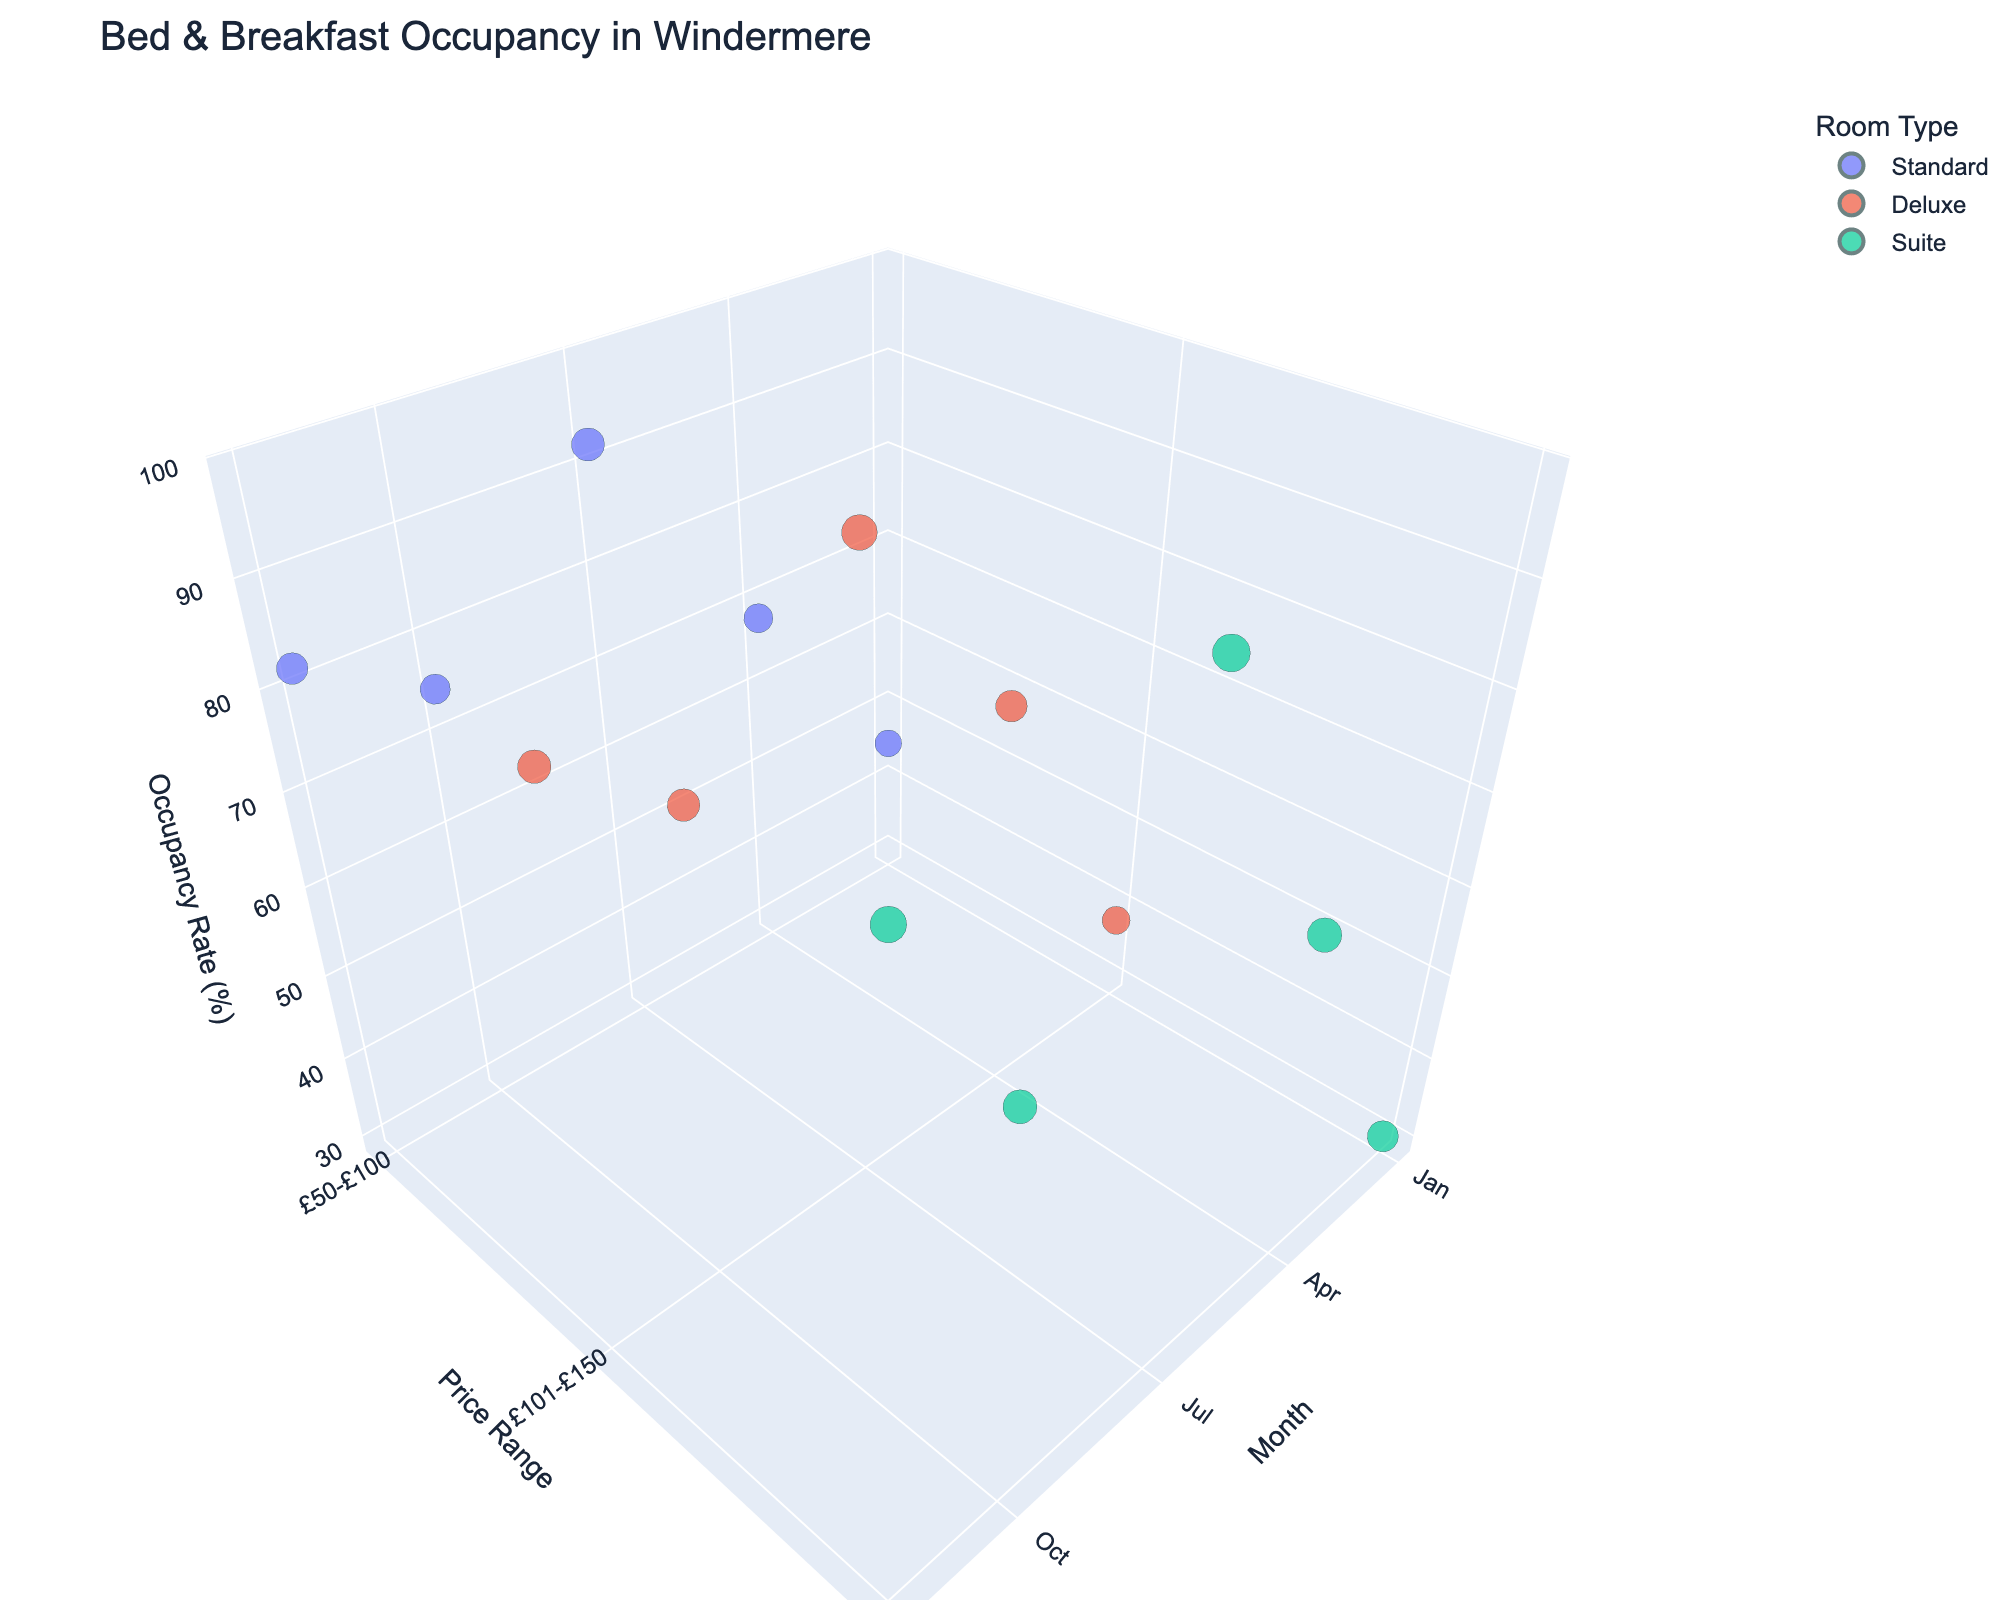What's the title of the chart? The title of the chart is the text displayed at the top of the figure, making it easily noticeable.
Answer: Bed & Breakfast Occupancy in Windermere What is the price range of Deluxe rooms? The price range is illustrated by the y-axis, and the Deluxe rooms are indicated by a specific color in the legend. Observing the corresponding price range shows it is £101-£150.
Answer: £101-£150 Which month has the highest occupancy rate for Suite rooms, and what is that rate? To determine this, locate the Suite room category by its color in the chart, and then identify the month with the highest z-axis (Occupancy Rate) value. July has the highest occupancy rate at 98%.
Answer: July, 98% Which room type typically has the longest average stay duration in December? Examine the bubble sizes in December (month on the x-axis) and compare the sizes for different room types. The largest bubble, indicating the longest average stay, belongs to Suite rooms.
Answer: Suite How does the occupancy rate for Standard rooms in January compare to the rate in December? Identify the Standard room category and compare the z-axis values (Occupancy Rate) for January and December. January has an occupancy rate of 45%, and December has 82%.
Answer: In December, it is higher Is the occupancy rate higher in April or October for Deluxe rooms, and by how much? Compare the z-axis values for Deluxe rooms in April and October. April has 72%, and October has 79%. Calculate the difference of 79% - 72%.
Answer: October, by 7% What's the difference in average stay duration between Deluxe and Suite rooms in July? Find the bubble sizes in July for both Deluxe and Suite rooms. Deluxe rooms have an average stay duration of 4.1 days, Suite rooms have 4.6 days. The difference is 4.6 - 4.1.
Answer: 0.5 days What trend can be observed about the occupancy rate of Suite rooms across the months? Examine the z-axis values (Occupancy Rate) for Suite rooms from January to December. Note the increasing trend from January to July, a dip in October, then an increase again in December.
Answer: Increasing, October dip, increase Which room type shows the most considerable change in occupancy rate between January and July? Look at the z-axis values (Occupancy Rate) for each room type in January and July, and note the changes. Standard rooms change from 45% to 92%, the largest shift.
Answer: Standard Which room type and month combination has the largest average stay duration, and what is that duration? Identify the largest bubble across all room types and months. Suite rooms in July have the largest bubble, hence the longest average stay duration.
Answer: Suite, July, 4.6 days 